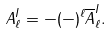<formula> <loc_0><loc_0><loc_500><loc_500>A ^ { I } _ { \ell } = - ( - ) ^ { \ell } \overline { A } ^ { I } _ { \ell } .</formula> 